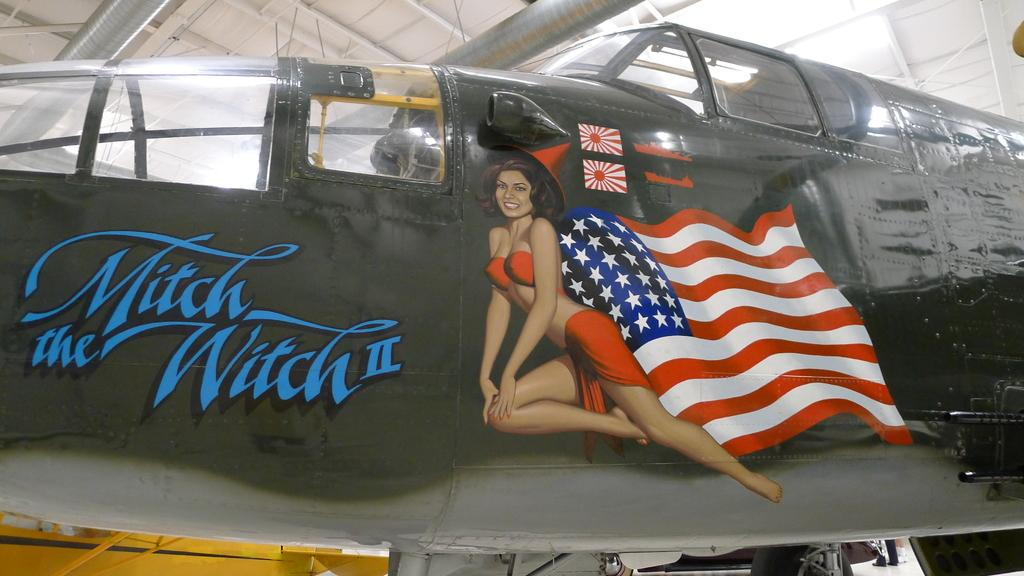<image>
Write a terse but informative summary of the picture. An American fighter plane that is called Mitch the Witch II. 